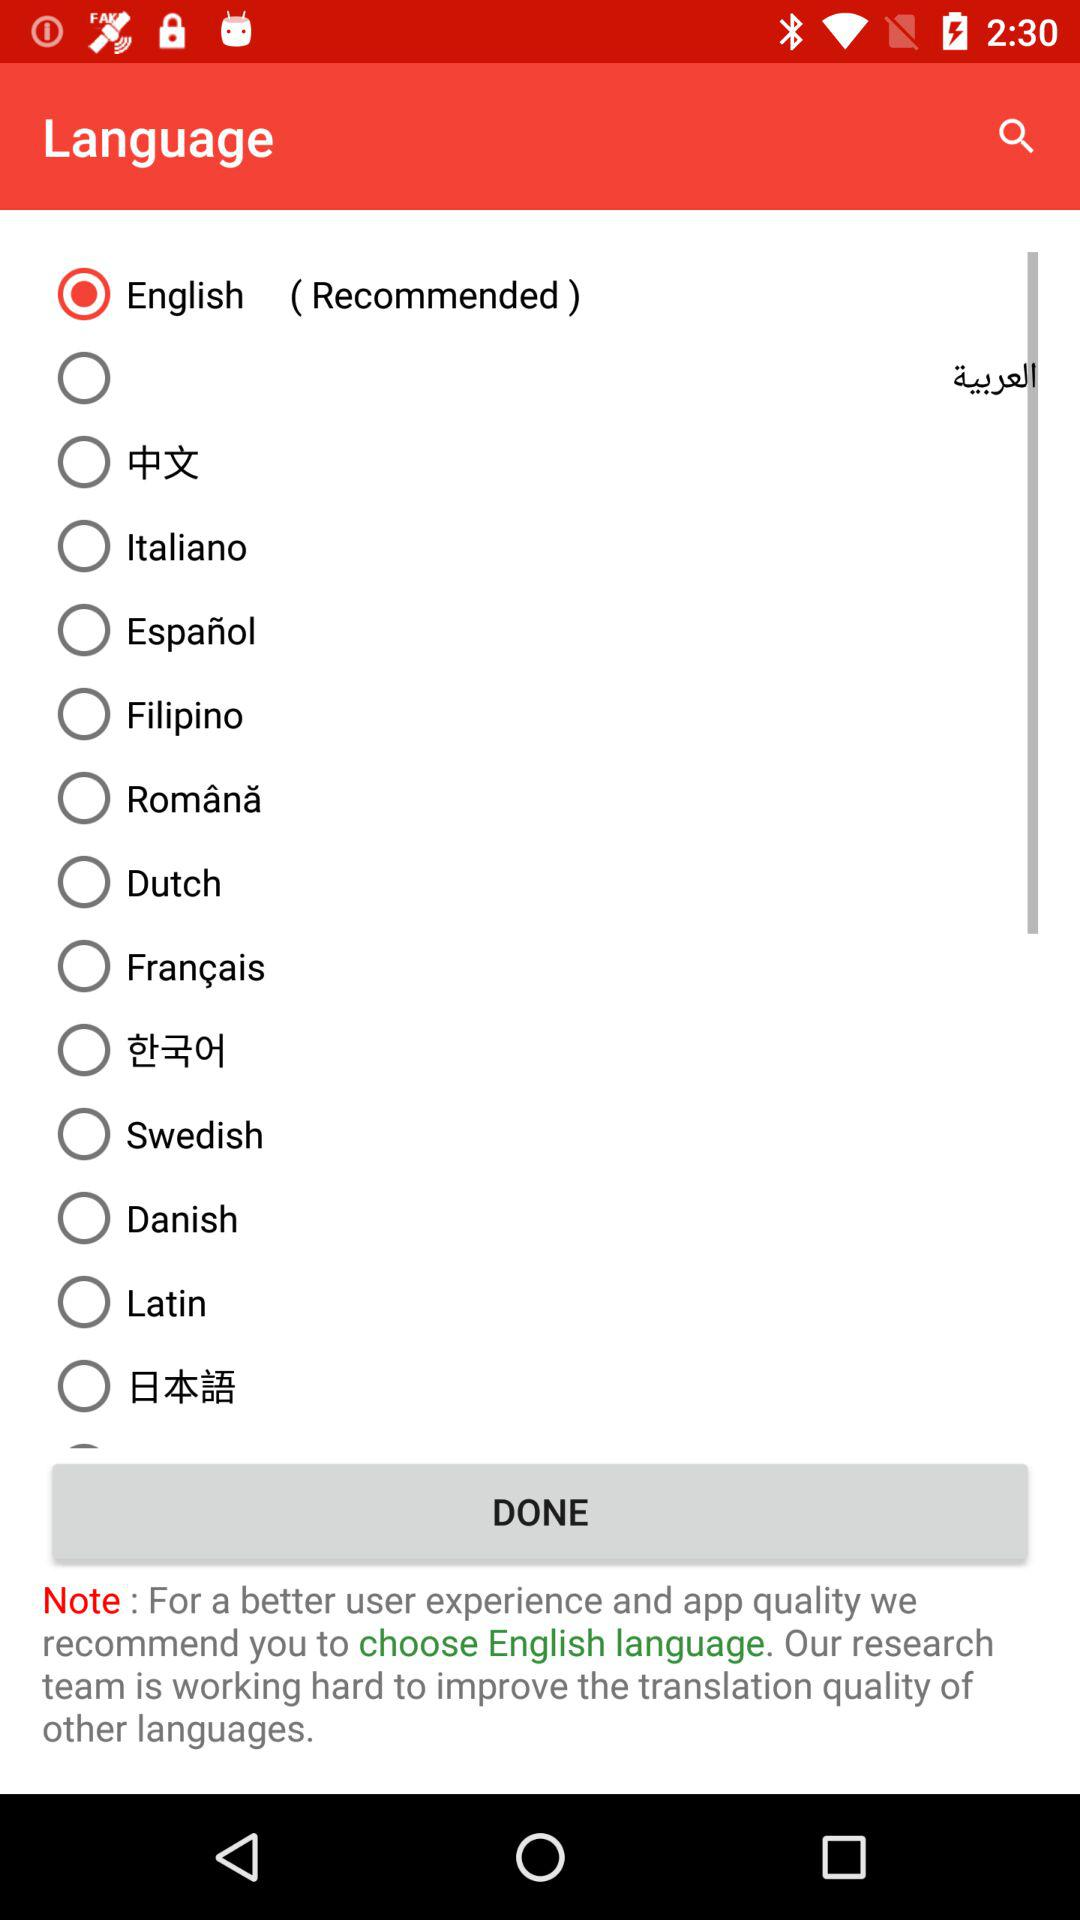Which language is selected? The selected language is English. 